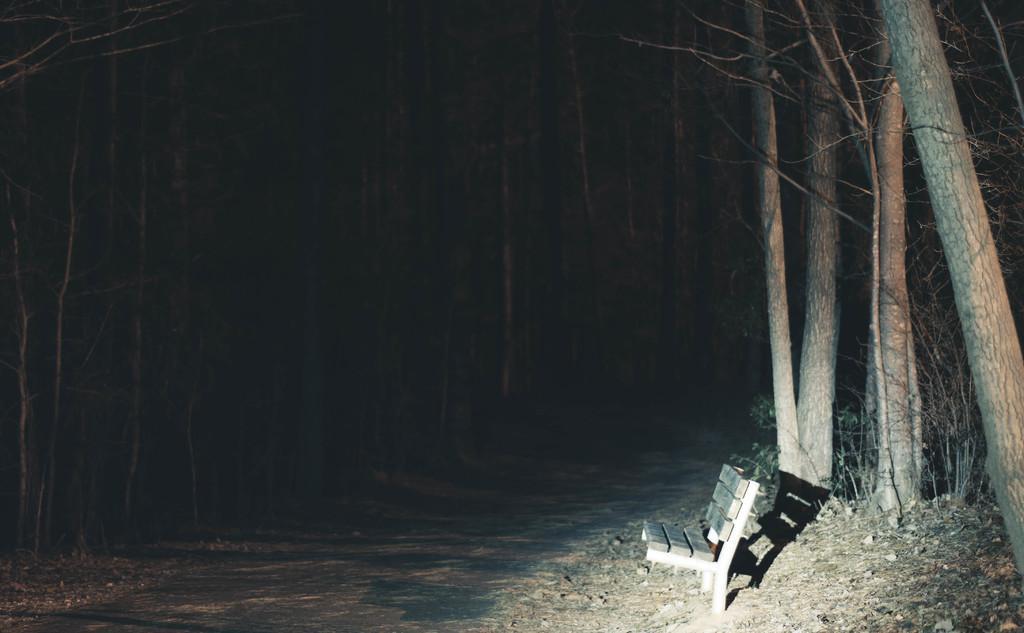How would you summarize this image in a sentence or two? In this image I can see, at the bottom it is the road. On the right side there is a bench and there are trees in the middle of an image. It is in the nighttime. 